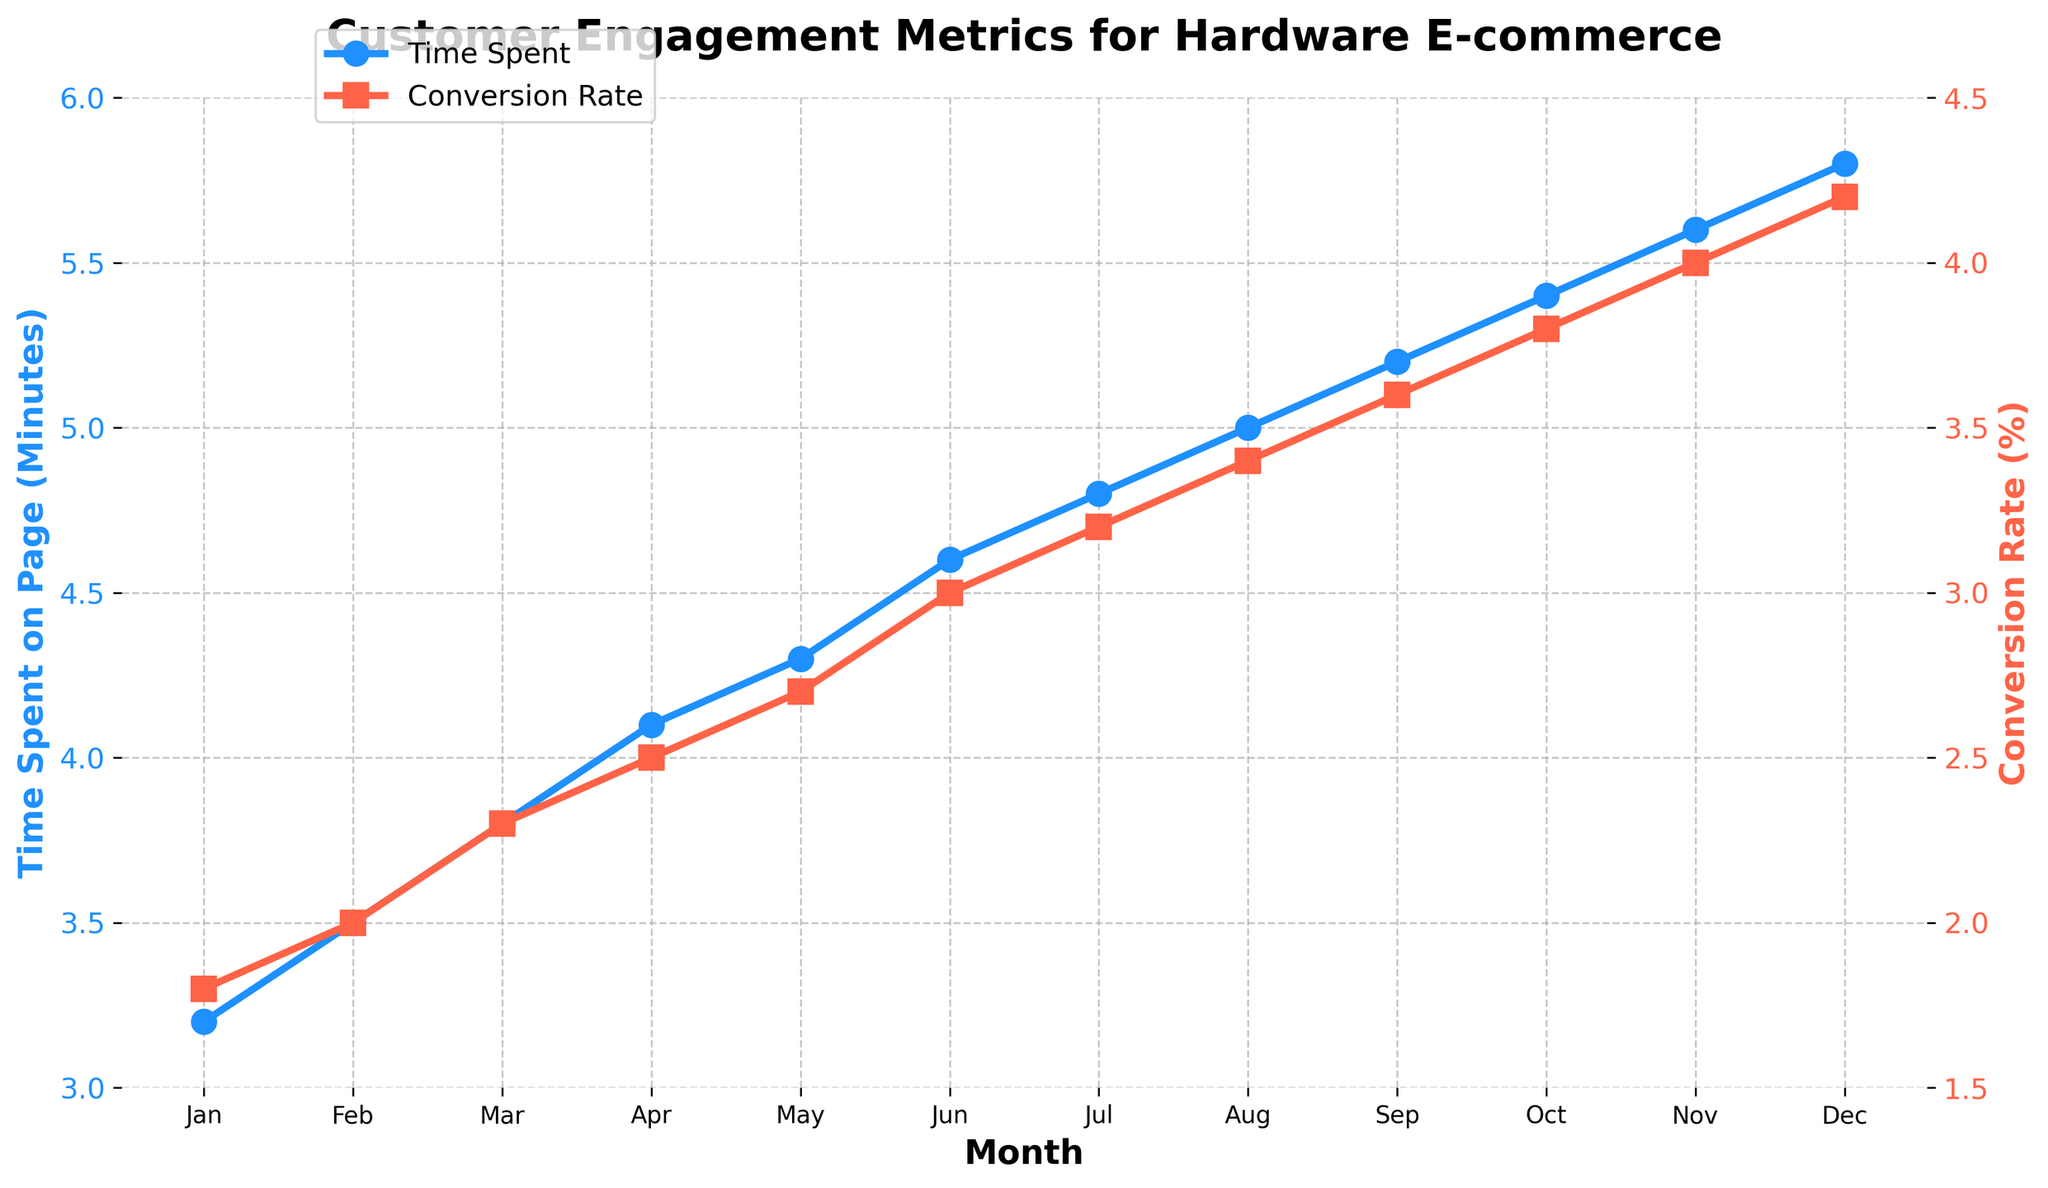What month has the highest time spent on page? Look at the blue line representing time spent on page and identify the month with the highest point. The highest point is in December.
Answer: December During which month is the conversion rate closest to 3.0%? Check the red line representing conversion rate and find the month where the rate is closest to 3.0%. June has a conversion rate of exactly 3.0%.
Answer: June What is the difference in time spent on page between January and December? Find the time spent on page values for January (3.2 minutes) and December (5.8 minutes) and subtract the January value from the December value. The difference is 5.8 - 3.2 = 2.6 minutes.
Answer: 2.6 minutes How does the conversion rate change from February to March? Look at the conversion rate values for February (2.0%) and March (2.3%). The rate increases from 2.0% to 2.3%.
Answer: Increases Is there any month where the time spent on page is exactly 5 minutes? Look at the blue line and identify if any month reaches exactly 5.0 minutes on the Y-axis. August has exactly 5.0 minutes.
Answer: August Which month shows the weakest engagement (lowest conversion rate)? Find the lowest point on the red line representing conversion rates. January has the lowest conversion rate at 1.8%.
Answer: January Which metric, time spent on page or conversion rate, shows a greater relative increase from January to December? Calculate the relative increase for both metrics. Time spent: (5.8 - 3.2) / 3.2 = 0.8125 (81.25%). Conversion rate: (4.2 - 1.8) / 1.8 = 1.3333 (133.33%). Conversion rate shows a greater relative increase.
Answer: Conversion rate What is the average conversion rate for the first three months? Sum the conversion rates for January (1.8%), February (2.0%), and March (2.3%) and then divide by 3. Average = (1.8 + 2.0 + 2.3) / 3 = 2.03%.
Answer: 2.03% Compare the trend lines for both metrics. How do they behave over the year? Observe both lines. Both the time spent on page (blue line) and the conversion rate (red line) trend upwards consistently over the year.
Answer: They both trend upwards Between which two consecutive months is the increase in the conversion rate the greatest? Calculate the month-to-month increase: From April to May, the increase is the largest, from 2.5% to 2.7% (0.2%).
Answer: April to May 